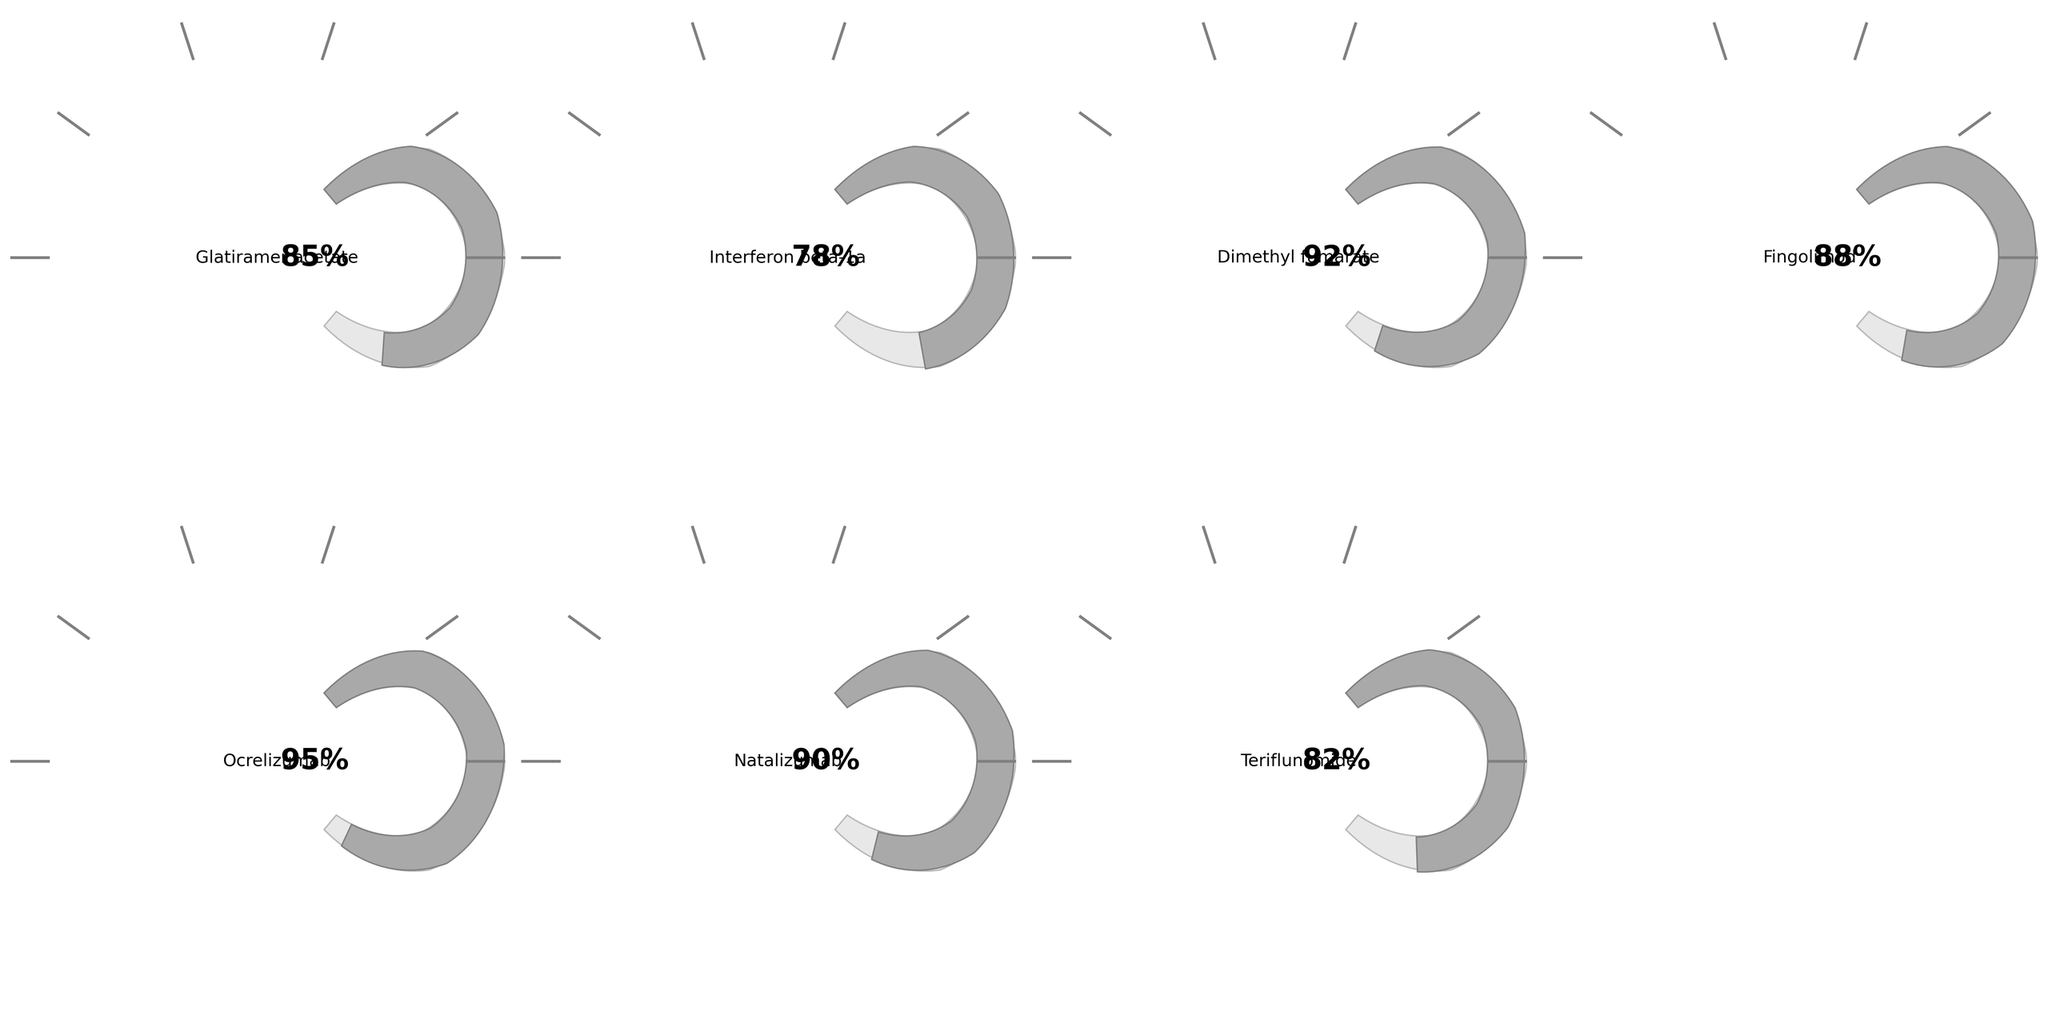How many total medications are represented in the figure? Count the number of distinct medications shown on the gauge charts. There are 7 (Glatiramer acetate, Interferon beta-1a, Dimethyl fumarate, Fingolimod, Ocrelizumab, Natalizumab, Teriflunomide).
Answer: 7 What is the average adherence level across all medications? Sum all adherence levels and divide by the number of medications: (85 + 78 + 92 + 88 + 95 + 90 + 82) / 7 = 88.57, which rounds to 88.6%.
Answer: 88.6% Which medication has the highest adherence? Identify the medication with the highest number on its gauge. The highest adherence value is 95%, which corresponds to Ocrelizumab.
Answer: Ocrelizumab What is the adherence level difference between the highest and lowest medications? The highest adherence is 95% (Ocrelizumab) and the lowest is 78% (Interferon beta-1a). Calculate 95 - 78 = 17%.
Answer: 17% Which medications have an adherence level higher than 90%? Identify medications with adherence levels exceeding 90%. These are Dimethyl fumarate (92%), Ocrelizumab (95%), and Natalizumab (90%).
Answer: Dimethyl fumarate, Ocrelizumab, Natalizumab What is the median adherence level among the medications? Arrange adherence levels in ascending order: 78, 82, 85, 88, 90, 92, 95. The median value, being the fourth in the ordered list, is 88% (Fingolimod).
Answer: 88% How many medications have an adherence level below 80%? Count the number of medications with adherence levels less than 80%. Only Interferon beta-1a (78%) qualifies.
Answer: 1 Is the adherence for Dimethyl fumarate higher or lower than that for Fingolimod? Compare the adherence levels of the two medications. Dimethyl fumarate has 92% adherence, and Fingolimod has 88%. Therefore, Dimethyl fumarate is higher.
Answer: Higher What is the range of adherence levels among the medications? Determine the range by subtracting the lowest adherence level from the highest. The highest is 95% (Ocrelizumab), and the lowest is 78% (Interferon beta-1a). Thus, 95 - 78 = 17%.
Answer: 17% Which medication's adherence is closest to the average adherence level? Calculate the differences between the average adherence (88.6%) and each medication's adherence level, then identify the smallest difference. Fingolimod (88%) is closest.
Answer: Fingolimod 